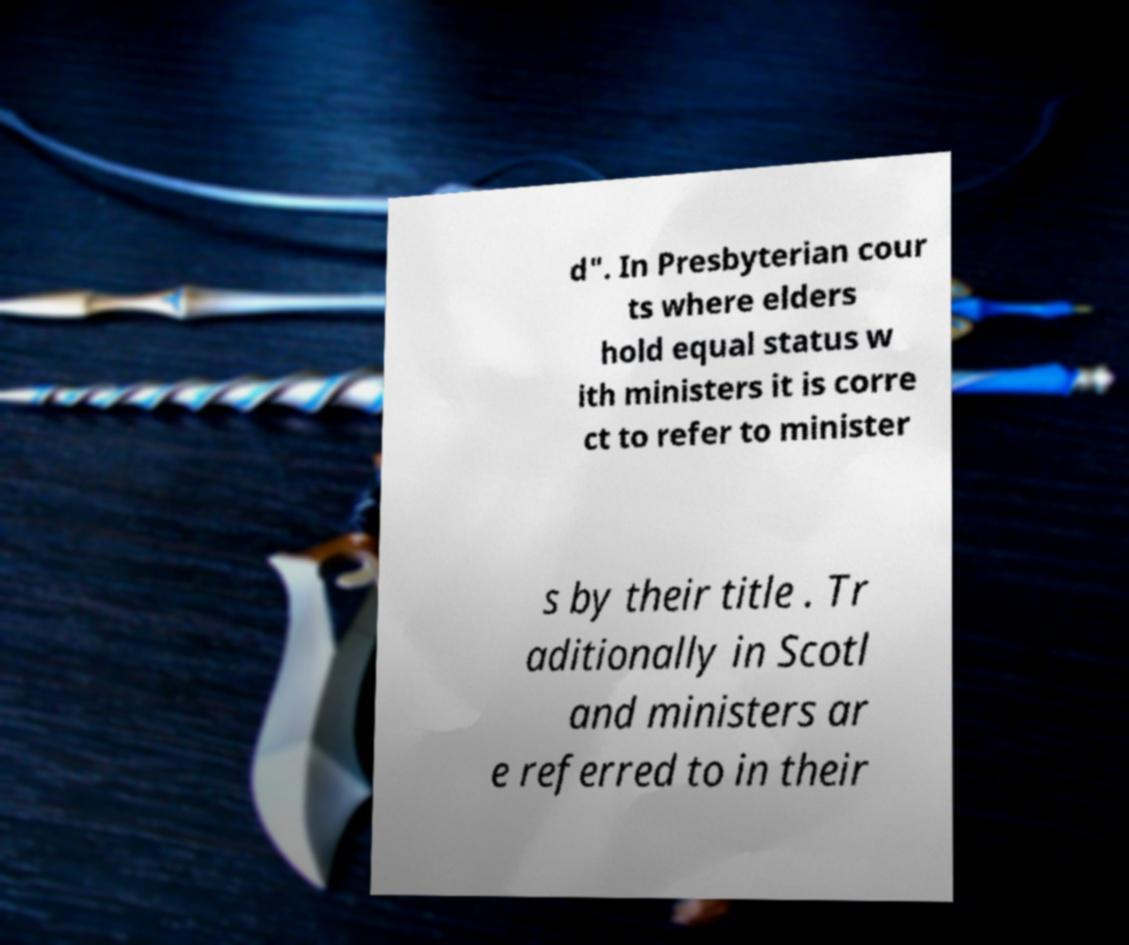I need the written content from this picture converted into text. Can you do that? d". In Presbyterian cour ts where elders hold equal status w ith ministers it is corre ct to refer to minister s by their title . Tr aditionally in Scotl and ministers ar e referred to in their 